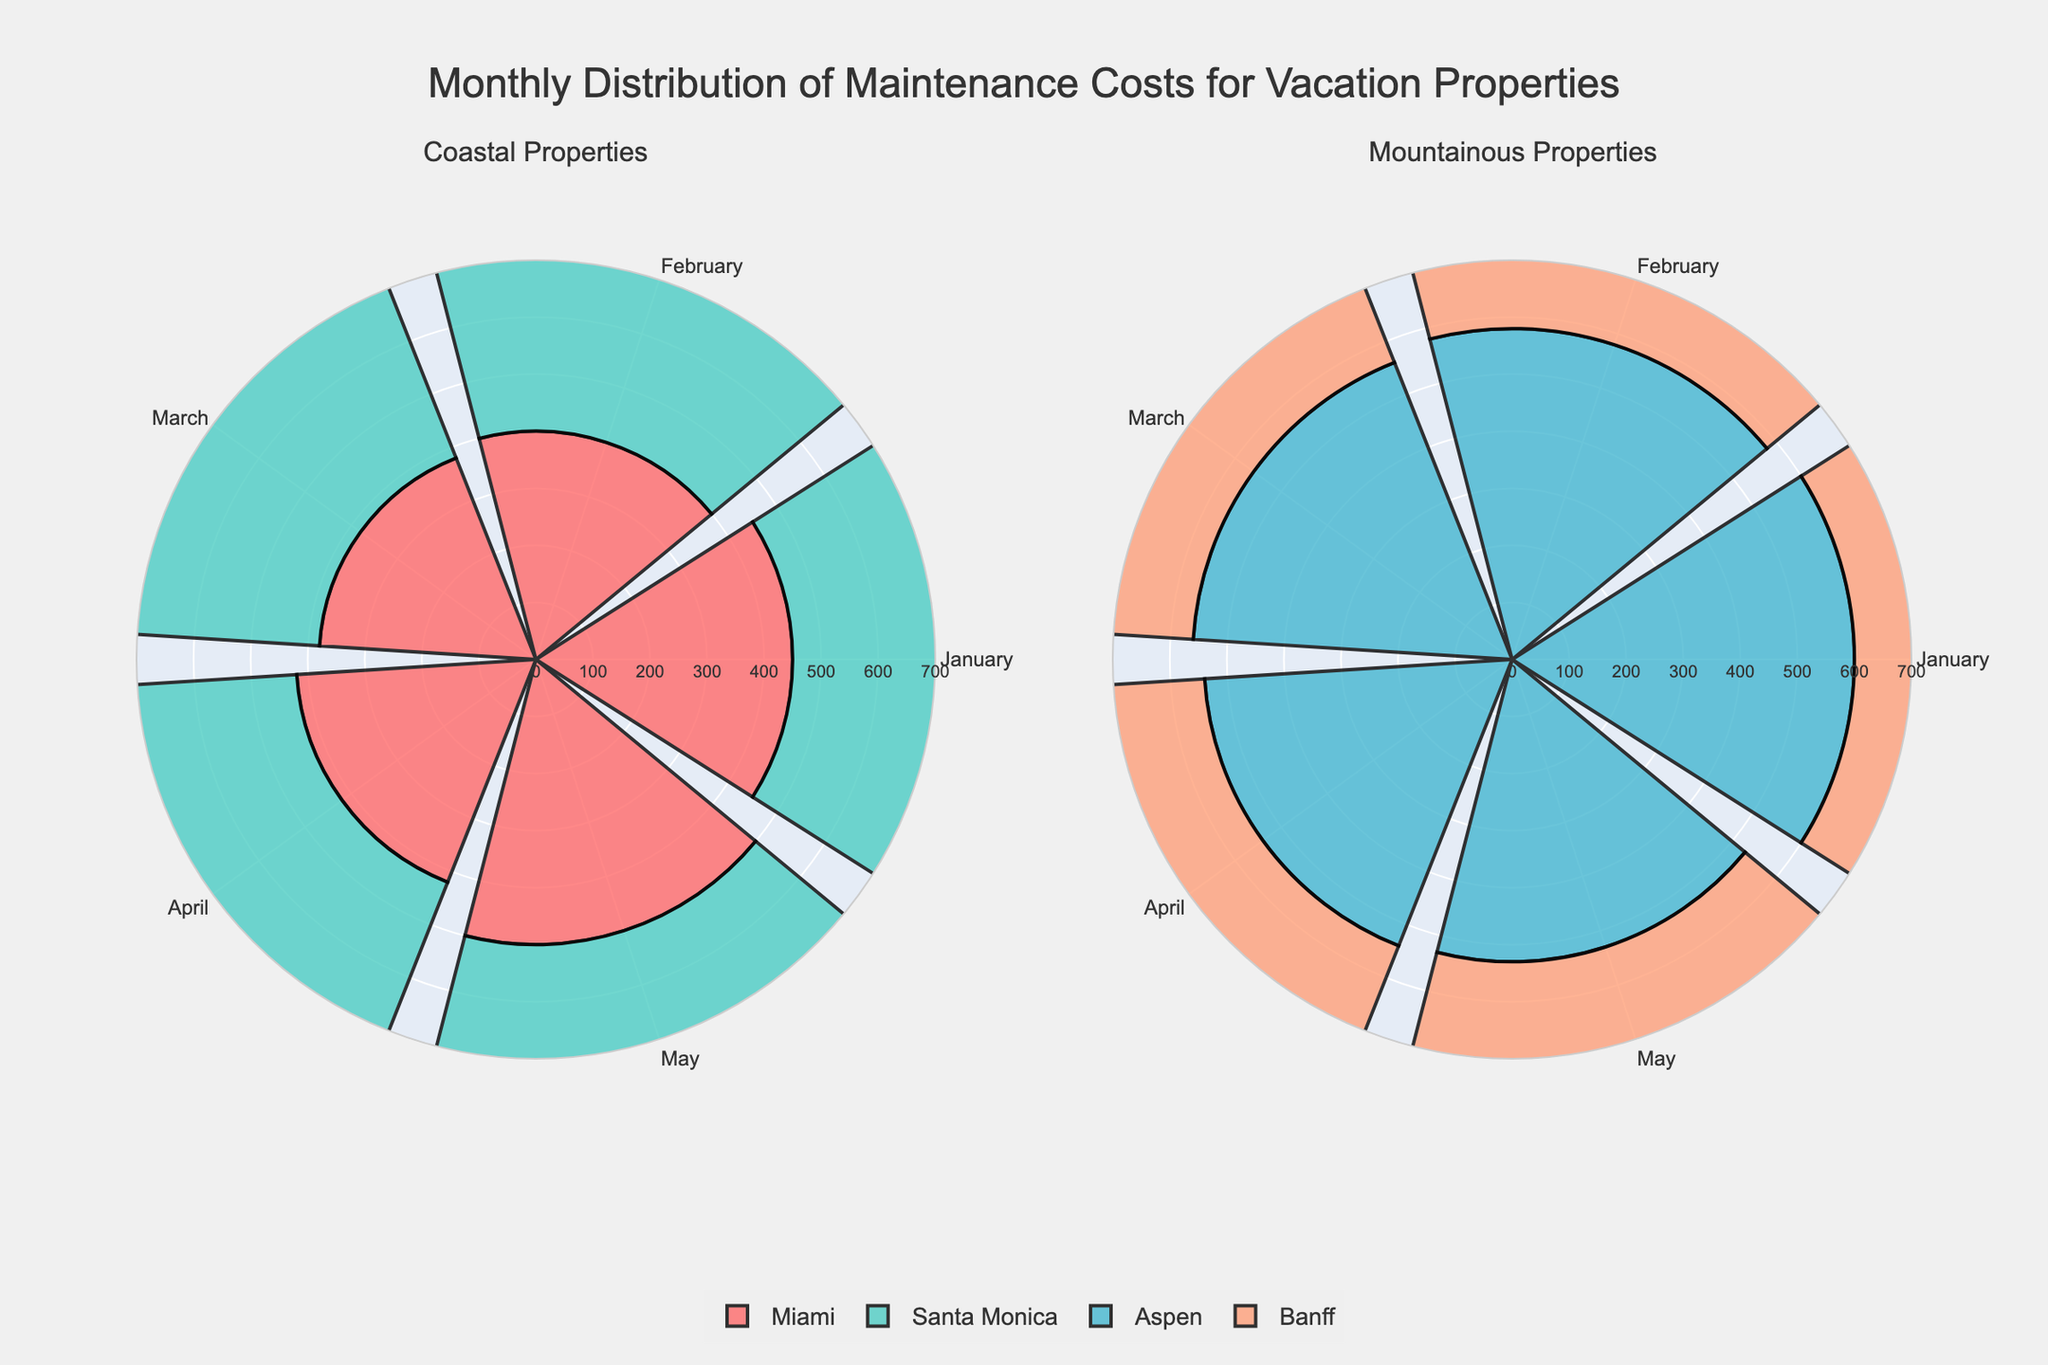Which region has the highest maintenance cost in January? According to the plot, Banff in the Mountainous Properties has the highest maintenance cost in January at 620.
Answer: Banff What month has the lowest maintenance cost for Miami? The plot shows that Miami has the lowest maintenance cost in March, with a cost of $380.
Answer: March On average, which region has higher maintenance costs across all months shown in the plots? To determine this, we'll calculate the average maintenance cost across all months for each region:      
- Coastal Properties: (450+400+380+420+500)+(470+460+450+500+520) = 5950/10 ≈ 450   
- Mountainous Properties: (600+580+560+540+530)+(620+590+580+570+560) = 6730/10 ≈ 560    
The average maintenance cost is higher for Mountainous Properties.
Answer: Mountainous Properties Which region shows the most variation in maintenance costs over the months? Looking at the plots, Banff in the Mountainous Properties shows a greater range of costs (from 560 to 620) compared to other regions.
Answer: Banff What is the combined maintenance cost for Miami and Santa Monica in February? The combined maintenance cost is the sum of February's costs for both Miami and Santa Monica: 400 + 460 = 860.
Answer: 860 Which region experiences an increase in maintenance costs from January to February? From the charts, Santa Monica and Banff both show an increase in maintenance costs from January to February.
Answer: Santa Monica, Banff Are there any months where all costs are the same for both coastal properties? No, according to the charts, there are no months where both Miami and Santa Monica have the same maintenance costs.
Answer: No What is the maintenance cost difference between the highest and lowest months for Aspen? The highest maintenance cost for Aspen is in January ($600), and the lowest is in May ($530). The difference is 600 - 530 = 70.
Answer: 70 Compare the maintenance costs between Miami and Aspen in April. Which one is higher? In April, Aspen has a maintenance cost of $540, which is higher than Miami's cost of $420.
Answer: Aspen What is the total maintenance cost for Santa Monica over the five months? The total maintenance cost for Santa Monica across all five months is: 470 + 460 + 450 + 500 + 520 = 2400.
Answer: 2400 